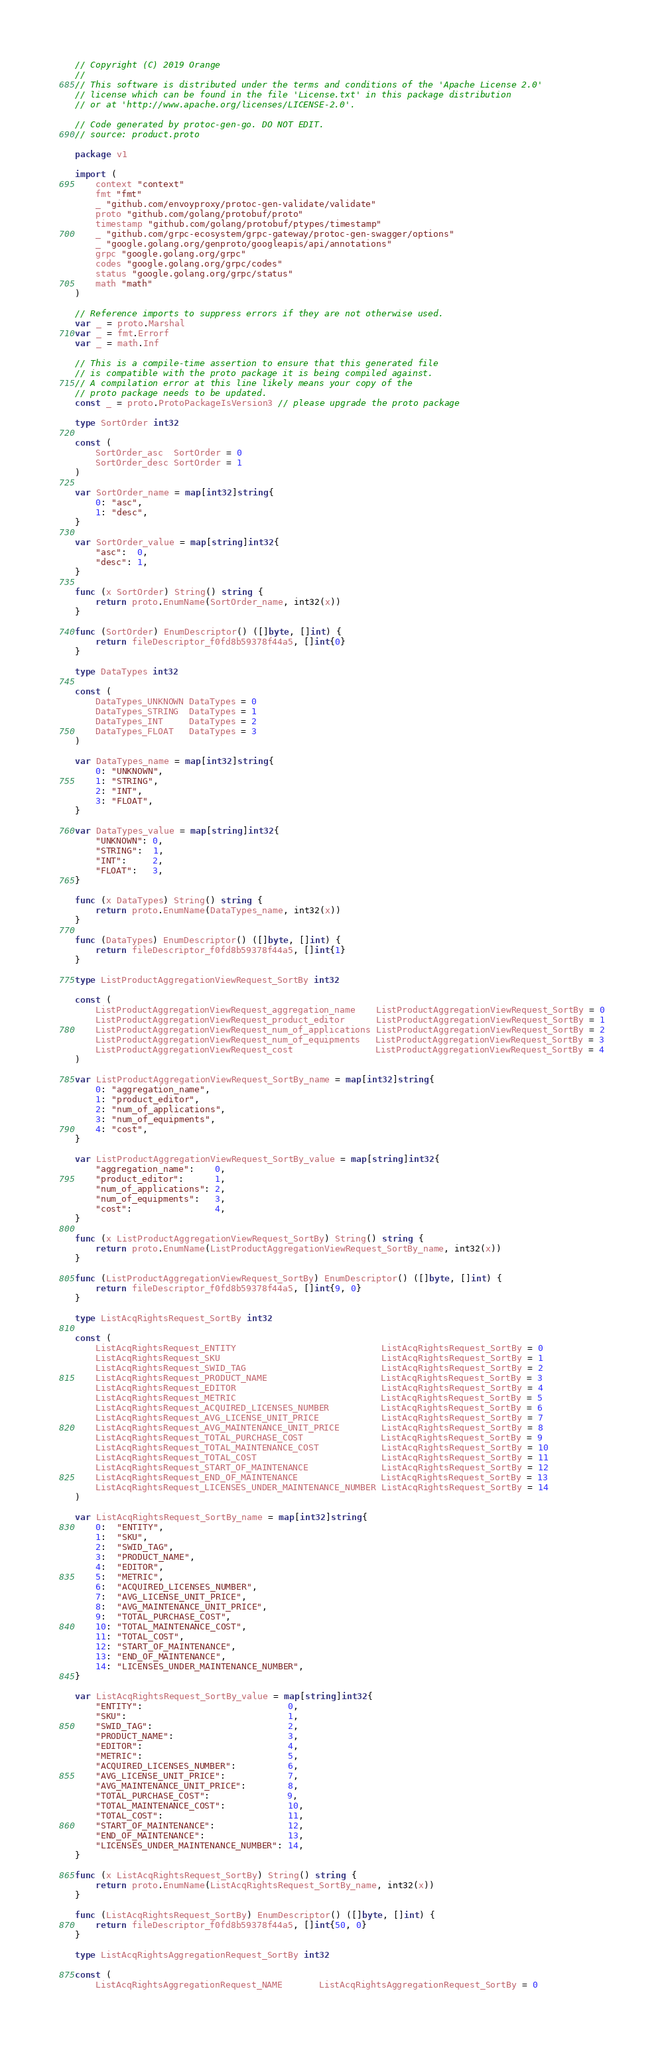<code> <loc_0><loc_0><loc_500><loc_500><_Go_>// Copyright (C) 2019 Orange
// 
// This software is distributed under the terms and conditions of the 'Apache License 2.0'
// license which can be found in the file 'License.txt' in this package distribution 
// or at 'http://www.apache.org/licenses/LICENSE-2.0'. 

// Code generated by protoc-gen-go. DO NOT EDIT.
// source: product.proto

package v1

import (
	context "context"
	fmt "fmt"
	_ "github.com/envoyproxy/protoc-gen-validate/validate"
	proto "github.com/golang/protobuf/proto"
	timestamp "github.com/golang/protobuf/ptypes/timestamp"
	_ "github.com/grpc-ecosystem/grpc-gateway/protoc-gen-swagger/options"
	_ "google.golang.org/genproto/googleapis/api/annotations"
	grpc "google.golang.org/grpc"
	codes "google.golang.org/grpc/codes"
	status "google.golang.org/grpc/status"
	math "math"
)

// Reference imports to suppress errors if they are not otherwise used.
var _ = proto.Marshal
var _ = fmt.Errorf
var _ = math.Inf

// This is a compile-time assertion to ensure that this generated file
// is compatible with the proto package it is being compiled against.
// A compilation error at this line likely means your copy of the
// proto package needs to be updated.
const _ = proto.ProtoPackageIsVersion3 // please upgrade the proto package

type SortOrder int32

const (
	SortOrder_asc  SortOrder = 0
	SortOrder_desc SortOrder = 1
)

var SortOrder_name = map[int32]string{
	0: "asc",
	1: "desc",
}

var SortOrder_value = map[string]int32{
	"asc":  0,
	"desc": 1,
}

func (x SortOrder) String() string {
	return proto.EnumName(SortOrder_name, int32(x))
}

func (SortOrder) EnumDescriptor() ([]byte, []int) {
	return fileDescriptor_f0fd8b59378f44a5, []int{0}
}

type DataTypes int32

const (
	DataTypes_UNKNOWN DataTypes = 0
	DataTypes_STRING  DataTypes = 1
	DataTypes_INT     DataTypes = 2
	DataTypes_FLOAT   DataTypes = 3
)

var DataTypes_name = map[int32]string{
	0: "UNKNOWN",
	1: "STRING",
	2: "INT",
	3: "FLOAT",
}

var DataTypes_value = map[string]int32{
	"UNKNOWN": 0,
	"STRING":  1,
	"INT":     2,
	"FLOAT":   3,
}

func (x DataTypes) String() string {
	return proto.EnumName(DataTypes_name, int32(x))
}

func (DataTypes) EnumDescriptor() ([]byte, []int) {
	return fileDescriptor_f0fd8b59378f44a5, []int{1}
}

type ListProductAggregationViewRequest_SortBy int32

const (
	ListProductAggregationViewRequest_aggregation_name    ListProductAggregationViewRequest_SortBy = 0
	ListProductAggregationViewRequest_product_editor      ListProductAggregationViewRequest_SortBy = 1
	ListProductAggregationViewRequest_num_of_applications ListProductAggregationViewRequest_SortBy = 2
	ListProductAggregationViewRequest_num_of_equipments   ListProductAggregationViewRequest_SortBy = 3
	ListProductAggregationViewRequest_cost                ListProductAggregationViewRequest_SortBy = 4
)

var ListProductAggregationViewRequest_SortBy_name = map[int32]string{
	0: "aggregation_name",
	1: "product_editor",
	2: "num_of_applications",
	3: "num_of_equipments",
	4: "cost",
}

var ListProductAggregationViewRequest_SortBy_value = map[string]int32{
	"aggregation_name":    0,
	"product_editor":      1,
	"num_of_applications": 2,
	"num_of_equipments":   3,
	"cost":                4,
}

func (x ListProductAggregationViewRequest_SortBy) String() string {
	return proto.EnumName(ListProductAggregationViewRequest_SortBy_name, int32(x))
}

func (ListProductAggregationViewRequest_SortBy) EnumDescriptor() ([]byte, []int) {
	return fileDescriptor_f0fd8b59378f44a5, []int{9, 0}
}

type ListAcqRightsRequest_SortBy int32

const (
	ListAcqRightsRequest_ENTITY                            ListAcqRightsRequest_SortBy = 0
	ListAcqRightsRequest_SKU                               ListAcqRightsRequest_SortBy = 1
	ListAcqRightsRequest_SWID_TAG                          ListAcqRightsRequest_SortBy = 2
	ListAcqRightsRequest_PRODUCT_NAME                      ListAcqRightsRequest_SortBy = 3
	ListAcqRightsRequest_EDITOR                            ListAcqRightsRequest_SortBy = 4
	ListAcqRightsRequest_METRIC                            ListAcqRightsRequest_SortBy = 5
	ListAcqRightsRequest_ACQUIRED_LICENSES_NUMBER          ListAcqRightsRequest_SortBy = 6
	ListAcqRightsRequest_AVG_LICENSE_UNIT_PRICE            ListAcqRightsRequest_SortBy = 7
	ListAcqRightsRequest_AVG_MAINTENANCE_UNIT_PRICE        ListAcqRightsRequest_SortBy = 8
	ListAcqRightsRequest_TOTAL_PURCHASE_COST               ListAcqRightsRequest_SortBy = 9
	ListAcqRightsRequest_TOTAL_MAINTENANCE_COST            ListAcqRightsRequest_SortBy = 10
	ListAcqRightsRequest_TOTAL_COST                        ListAcqRightsRequest_SortBy = 11
	ListAcqRightsRequest_START_OF_MAINTENANCE              ListAcqRightsRequest_SortBy = 12
	ListAcqRightsRequest_END_OF_MAINTENANCE                ListAcqRightsRequest_SortBy = 13
	ListAcqRightsRequest_LICENSES_UNDER_MAINTENANCE_NUMBER ListAcqRightsRequest_SortBy = 14
)

var ListAcqRightsRequest_SortBy_name = map[int32]string{
	0:  "ENTITY",
	1:  "SKU",
	2:  "SWID_TAG",
	3:  "PRODUCT_NAME",
	4:  "EDITOR",
	5:  "METRIC",
	6:  "ACQUIRED_LICENSES_NUMBER",
	7:  "AVG_LICENSE_UNIT_PRICE",
	8:  "AVG_MAINTENANCE_UNIT_PRICE",
	9:  "TOTAL_PURCHASE_COST",
	10: "TOTAL_MAINTENANCE_COST",
	11: "TOTAL_COST",
	12: "START_OF_MAINTENANCE",
	13: "END_OF_MAINTENANCE",
	14: "LICENSES_UNDER_MAINTENANCE_NUMBER",
}

var ListAcqRightsRequest_SortBy_value = map[string]int32{
	"ENTITY":                            0,
	"SKU":                               1,
	"SWID_TAG":                          2,
	"PRODUCT_NAME":                      3,
	"EDITOR":                            4,
	"METRIC":                            5,
	"ACQUIRED_LICENSES_NUMBER":          6,
	"AVG_LICENSE_UNIT_PRICE":            7,
	"AVG_MAINTENANCE_UNIT_PRICE":        8,
	"TOTAL_PURCHASE_COST":               9,
	"TOTAL_MAINTENANCE_COST":            10,
	"TOTAL_COST":                        11,
	"START_OF_MAINTENANCE":              12,
	"END_OF_MAINTENANCE":                13,
	"LICENSES_UNDER_MAINTENANCE_NUMBER": 14,
}

func (x ListAcqRightsRequest_SortBy) String() string {
	return proto.EnumName(ListAcqRightsRequest_SortBy_name, int32(x))
}

func (ListAcqRightsRequest_SortBy) EnumDescriptor() ([]byte, []int) {
	return fileDescriptor_f0fd8b59378f44a5, []int{50, 0}
}

type ListAcqRightsAggregationRequest_SortBy int32

const (
	ListAcqRightsAggregationRequest_NAME       ListAcqRightsAggregationRequest_SortBy = 0</code> 